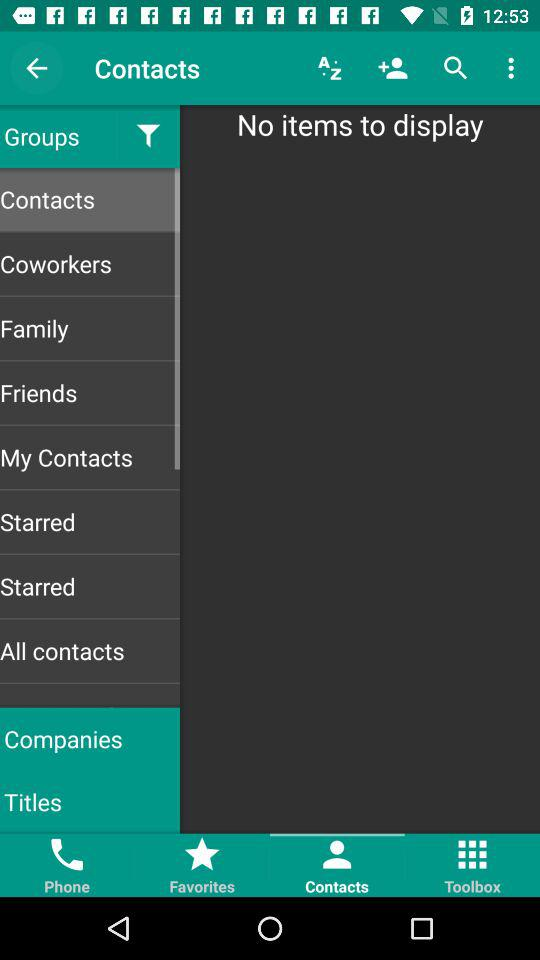Which tab is currently selected? The selected tab is "Contacts". 